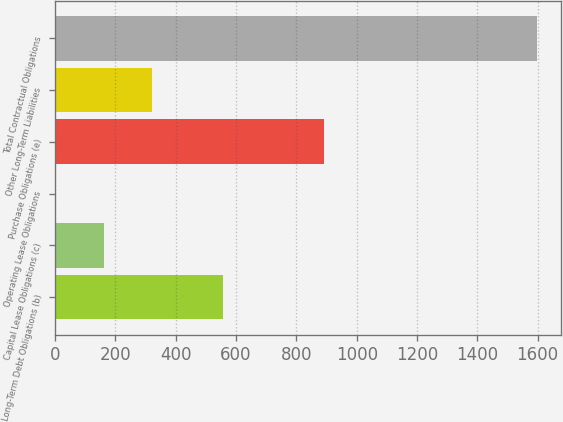<chart> <loc_0><loc_0><loc_500><loc_500><bar_chart><fcel>Long-Term Debt Obligations (b)<fcel>Capital Lease Obligations (c)<fcel>Operating Lease Obligations<fcel>Purchase Obligations (e)<fcel>Other Long-Term Liabilities<fcel>Total Contractual Obligations<nl><fcel>556.3<fcel>163.36<fcel>3.9<fcel>892.3<fcel>322.82<fcel>1598.5<nl></chart> 